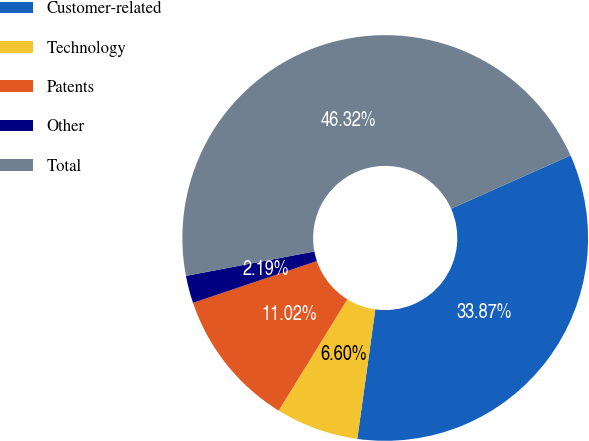<chart> <loc_0><loc_0><loc_500><loc_500><pie_chart><fcel>Customer-related<fcel>Technology<fcel>Patents<fcel>Other<fcel>Total<nl><fcel>33.87%<fcel>6.6%<fcel>11.02%<fcel>2.19%<fcel>46.32%<nl></chart> 